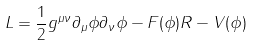Convert formula to latex. <formula><loc_0><loc_0><loc_500><loc_500>L = \frac { 1 } { 2 } g ^ { \mu \nu } \partial _ { \mu } \phi \partial _ { \nu } \phi - F ( \phi ) R - V ( \phi )</formula> 